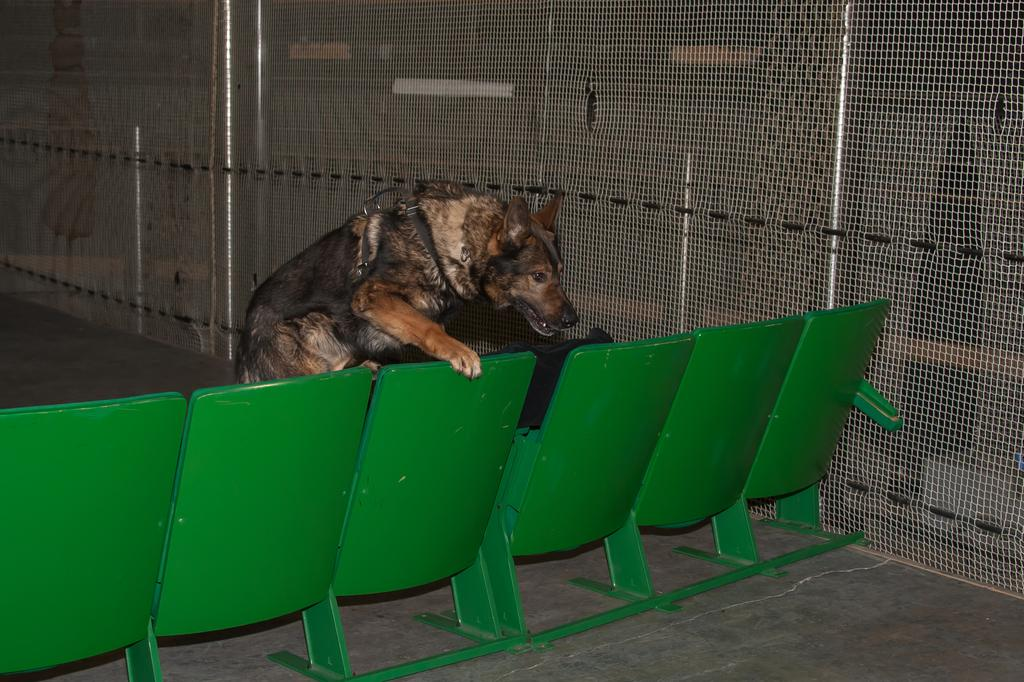What animal can be seen in the picture? There is a dog in the picture. What is the dog doing in the image? The dog is sitting on a chair. What other objects are present in the image? There is a pole and a fence in the image. What does the dog hate in the image? There is no indication in the image that the dog hates anything, as the dog's emotions or preferences are not visible. 